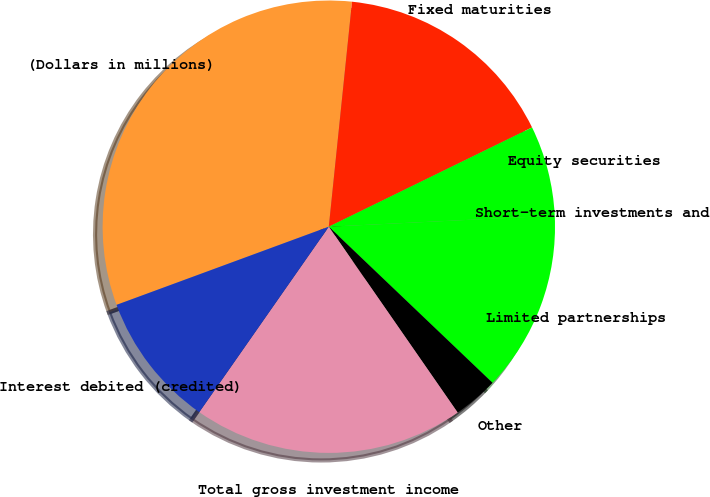Convert chart. <chart><loc_0><loc_0><loc_500><loc_500><pie_chart><fcel>(Dollars in millions)<fcel>Fixed maturities<fcel>Equity securities<fcel>Short-term investments and<fcel>Limited partnerships<fcel>Other<fcel>Total gross investment income<fcel>Interest debited (credited)<nl><fcel>32.25%<fcel>16.13%<fcel>6.45%<fcel>0.0%<fcel>12.9%<fcel>3.23%<fcel>19.35%<fcel>9.68%<nl></chart> 